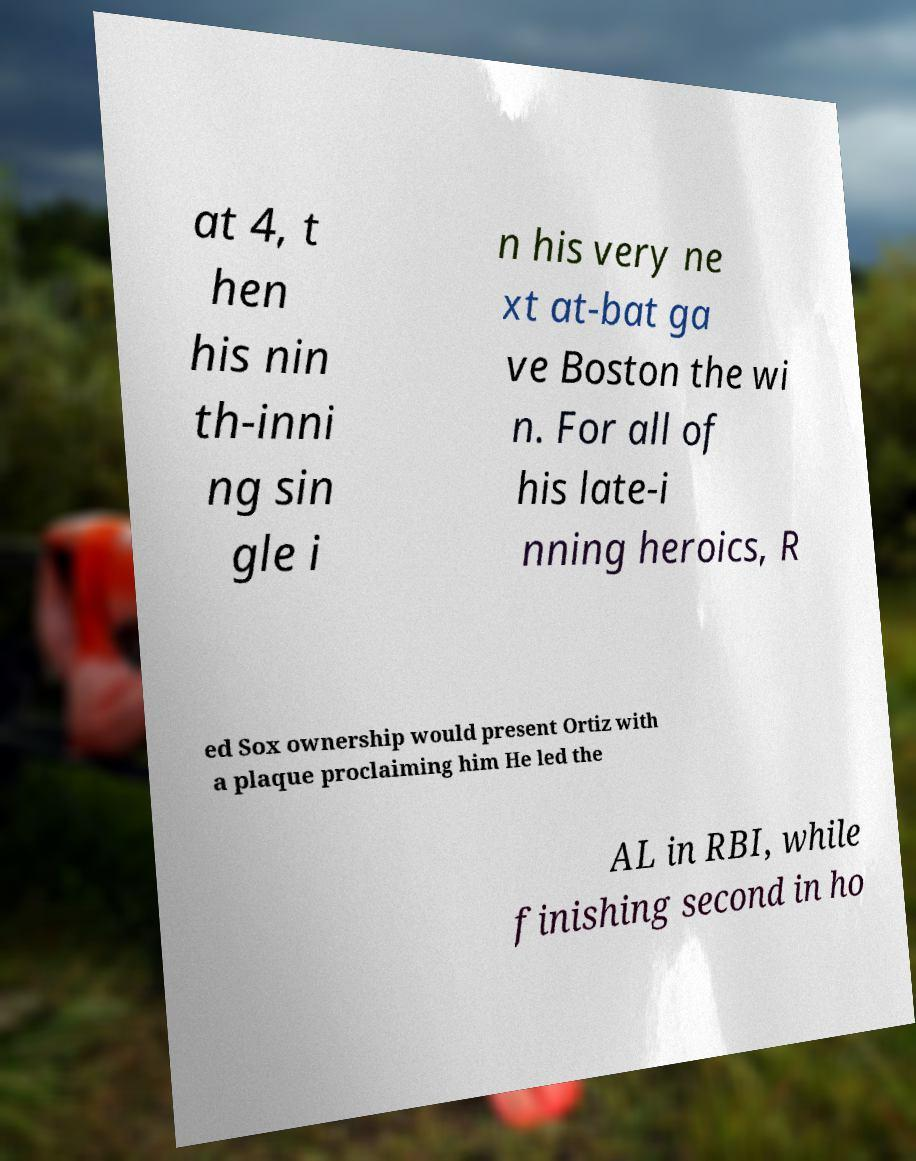Could you extract and type out the text from this image? at 4, t hen his nin th-inni ng sin gle i n his very ne xt at-bat ga ve Boston the wi n. For all of his late-i nning heroics, R ed Sox ownership would present Ortiz with a plaque proclaiming him He led the AL in RBI, while finishing second in ho 